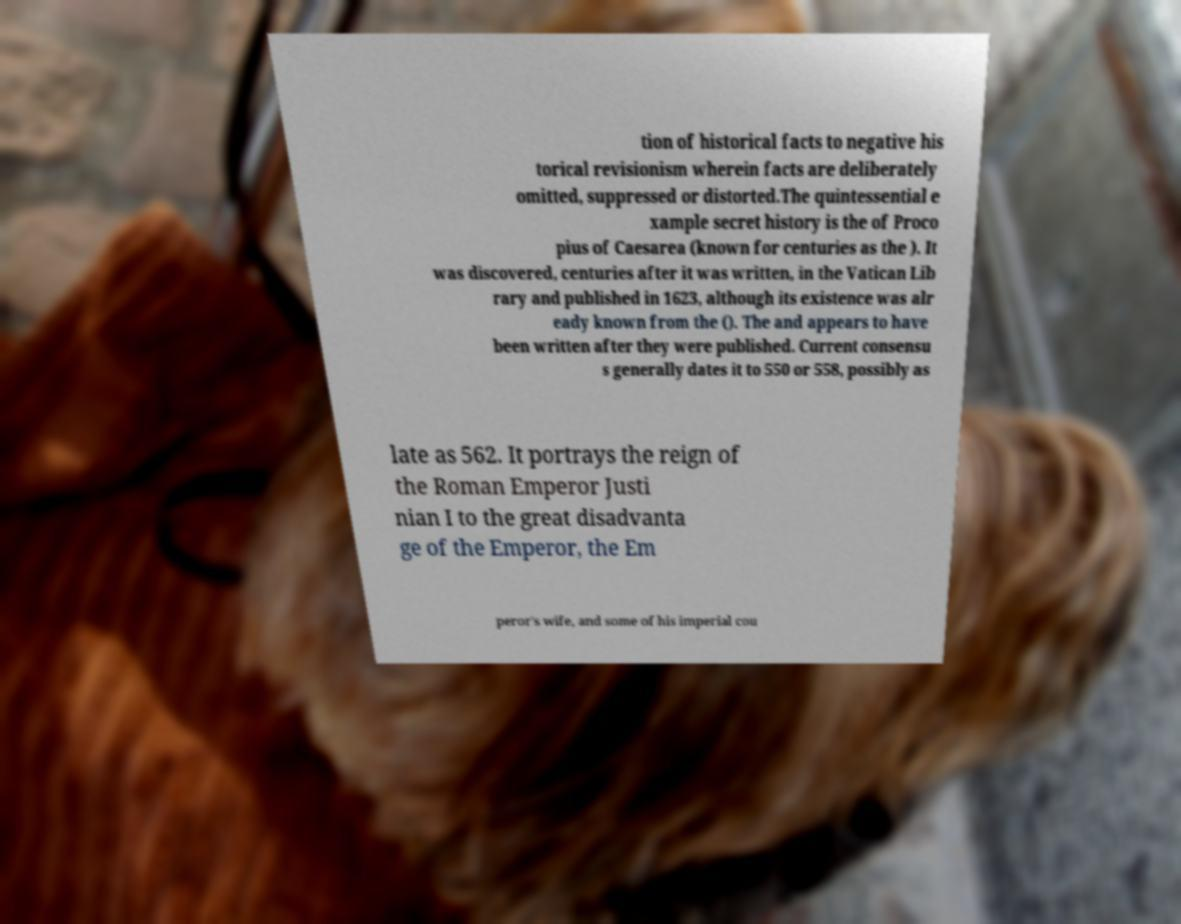For documentation purposes, I need the text within this image transcribed. Could you provide that? tion of historical facts to negative his torical revisionism wherein facts are deliberately omitted, suppressed or distorted.The quintessential e xample secret history is the of Proco pius of Caesarea (known for centuries as the ). It was discovered, centuries after it was written, in the Vatican Lib rary and published in 1623, although its existence was alr eady known from the (). The and appears to have been written after they were published. Current consensu s generally dates it to 550 or 558, possibly as late as 562. It portrays the reign of the Roman Emperor Justi nian I to the great disadvanta ge of the Emperor, the Em peror's wife, and some of his imperial cou 